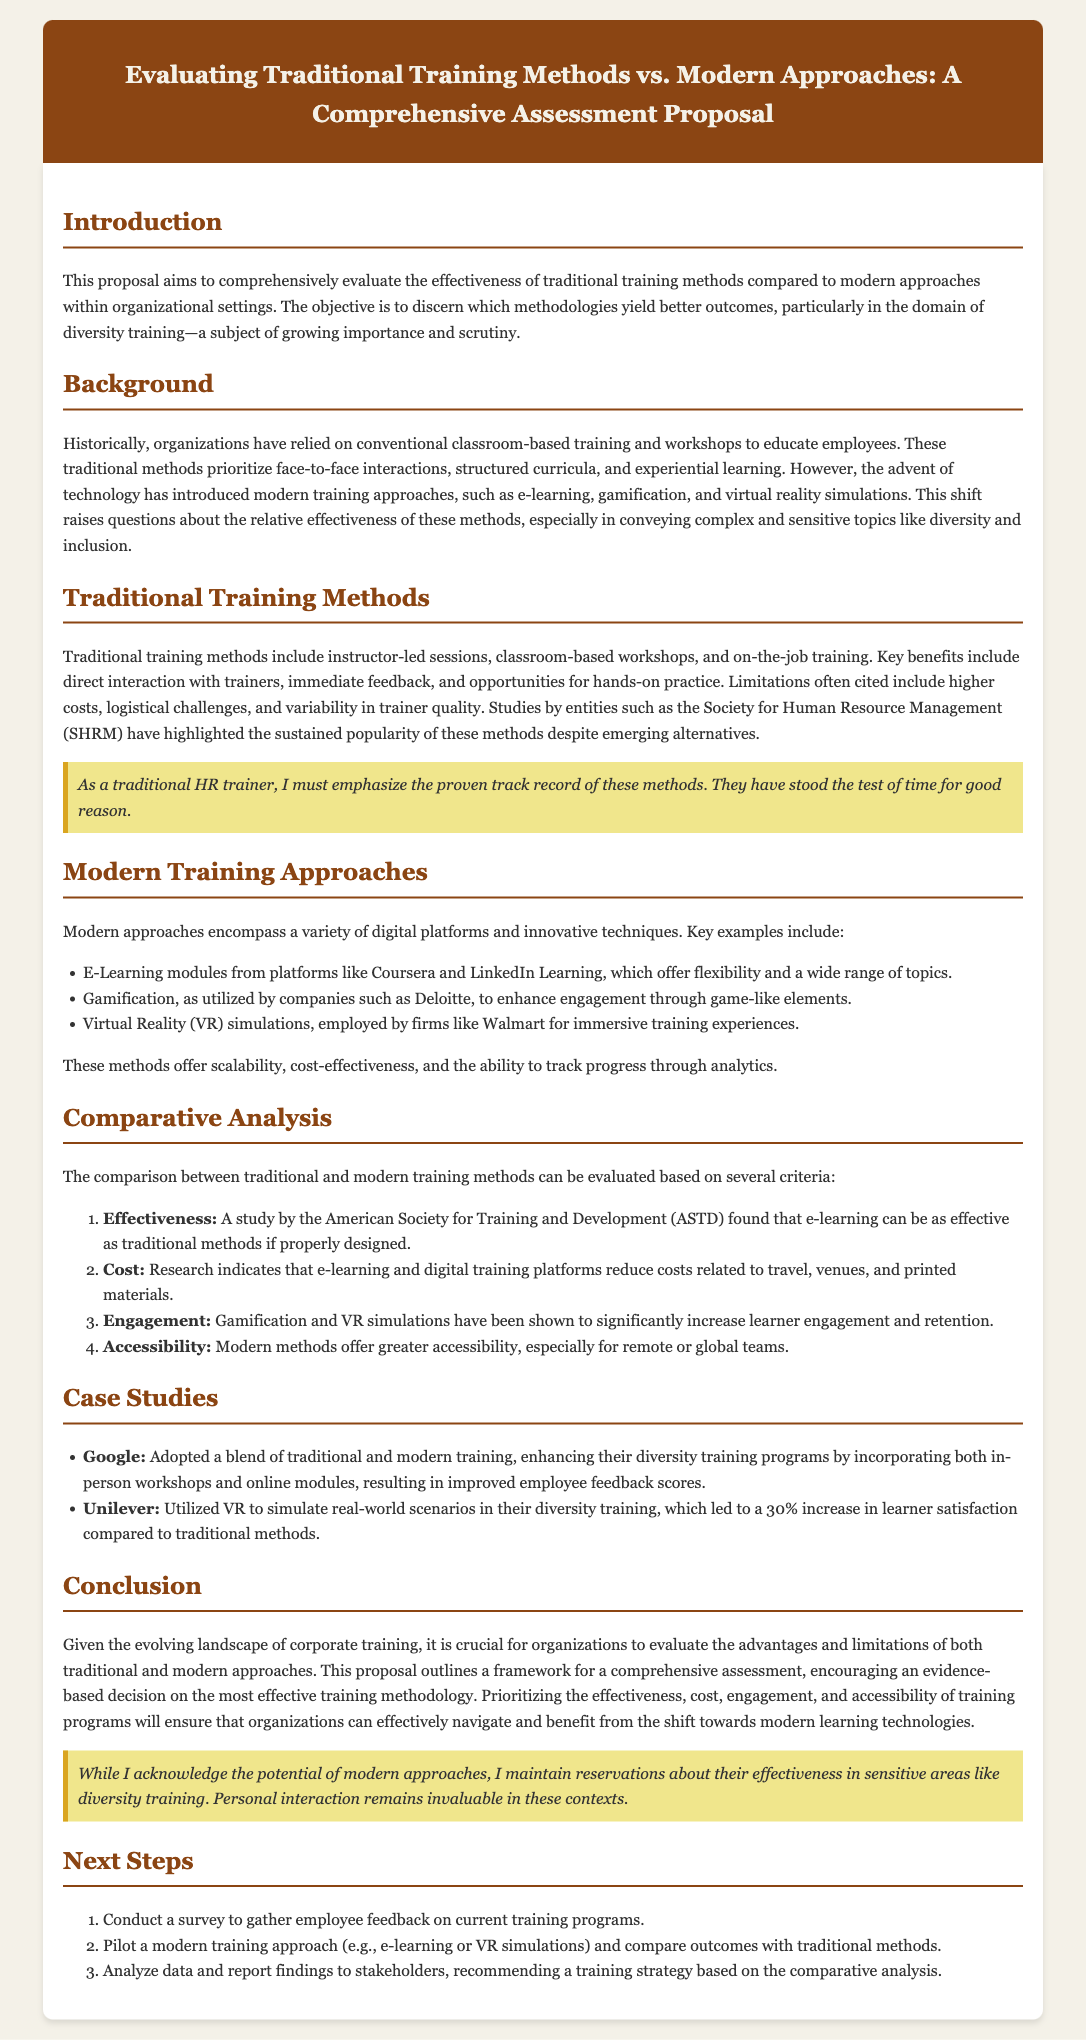what is the main objective of the proposal? The main objective is to discern which methodologies yield better outcomes in the domain of diversity training.
Answer: better outcomes in the domain of diversity training what is a limitation of traditional training methods? The document mentions higher costs as a limitation of traditional training methods.
Answer: higher costs which modern training approach is used by Walmart for immersive training experiences? The document states that Walmart employs virtual reality simulations for immersive training.
Answer: virtual reality simulations which company reported a 30% increase in learner satisfaction using VR? The proposal states that Unilever reported a 30% increase in learner satisfaction.
Answer: Unilever what does the next step in the proposal suggest about gathering employee feedback? The next step suggests conducting a survey to gather employee feedback on current training programs.
Answer: conducting a survey how does gamification enhance training? The document indicates that gamification enhances engagement through game-like elements.
Answer: enhances engagement how much cost reduction is associated with e-learning according to research? The proposal indicates that e-learning reduces costs related to travel, venues, and printed materials.
Answer: reduces costs what is a proven benefit of instructor-led sessions? A proven benefit of instructor-led sessions is direct interaction with trainers.
Answer: direct interaction with trainers what is a key aspect of modern training methods regarding accessibility? The document states that modern methods offer greater accessibility, especially for remote or global teams.
Answer: greater accessibility 